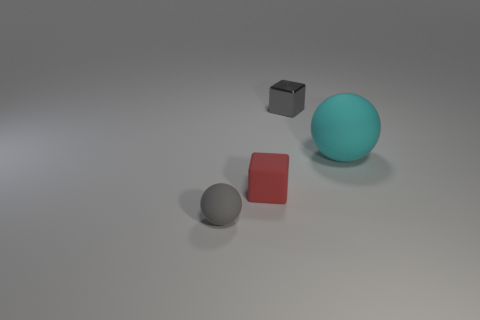Does the shiny thing have the same color as the small matte ball?
Offer a terse response. Yes. Is there a red metal ball that has the same size as the red matte thing?
Provide a succinct answer. No. Does the rubber ball that is to the left of the large thing have the same color as the small shiny thing?
Your answer should be compact. Yes. How many green objects are either metal cubes or tiny cubes?
Provide a short and direct response. 0. What number of other large spheres have the same color as the large matte sphere?
Your answer should be very brief. 0. Does the tiny red cube have the same material as the tiny gray block?
Provide a succinct answer. No. There is a small matte block that is right of the tiny matte sphere; how many metallic blocks are behind it?
Provide a short and direct response. 1. Does the gray block have the same size as the red block?
Ensure brevity in your answer.  Yes. What number of gray cubes are the same material as the gray sphere?
Your answer should be compact. 0. What is the size of the other gray rubber object that is the same shape as the large thing?
Offer a very short reply. Small. 